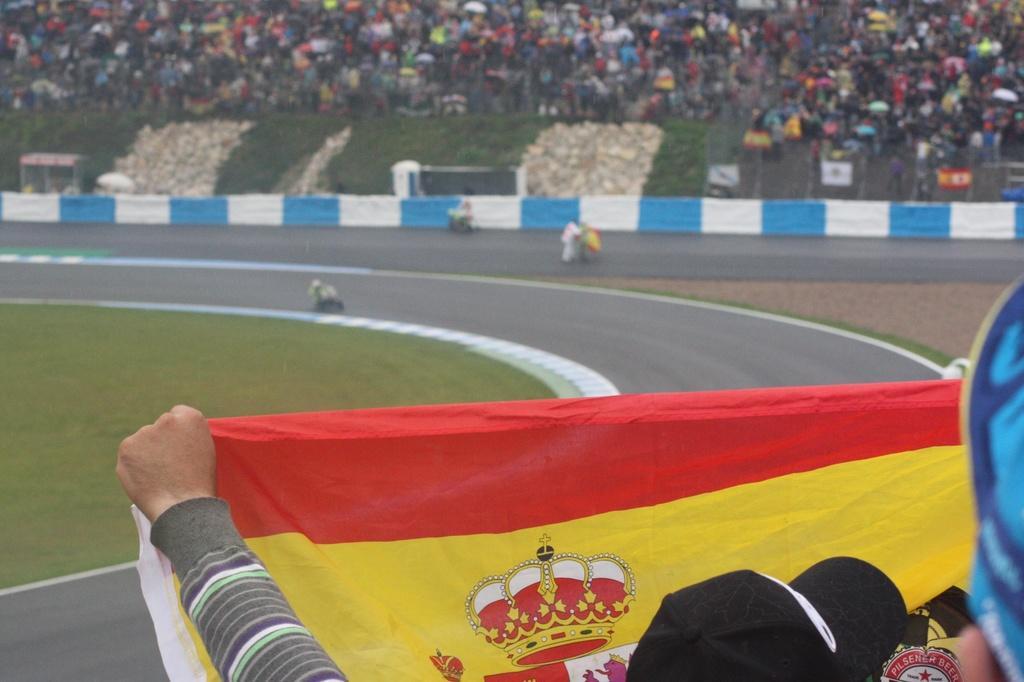Describe this image in one or two sentences. In this image at the bottom we can see a person holding a cloth in the hand and there are objects. In the background the image is blur but we can see few persons are riding bikes on the road, objects, fence, boards, many people and grass. 